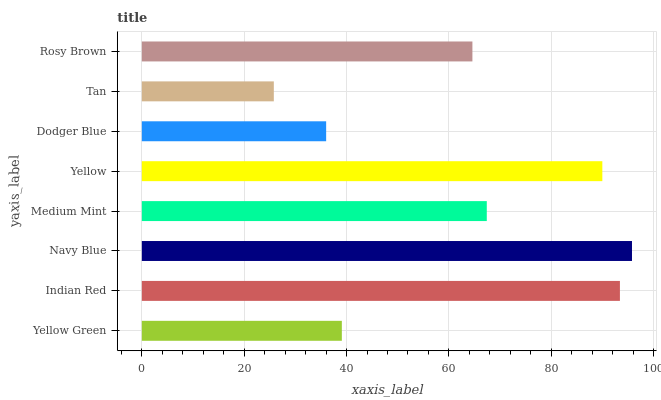Is Tan the minimum?
Answer yes or no. Yes. Is Navy Blue the maximum?
Answer yes or no. Yes. Is Indian Red the minimum?
Answer yes or no. No. Is Indian Red the maximum?
Answer yes or no. No. Is Indian Red greater than Yellow Green?
Answer yes or no. Yes. Is Yellow Green less than Indian Red?
Answer yes or no. Yes. Is Yellow Green greater than Indian Red?
Answer yes or no. No. Is Indian Red less than Yellow Green?
Answer yes or no. No. Is Medium Mint the high median?
Answer yes or no. Yes. Is Rosy Brown the low median?
Answer yes or no. Yes. Is Tan the high median?
Answer yes or no. No. Is Medium Mint the low median?
Answer yes or no. No. 